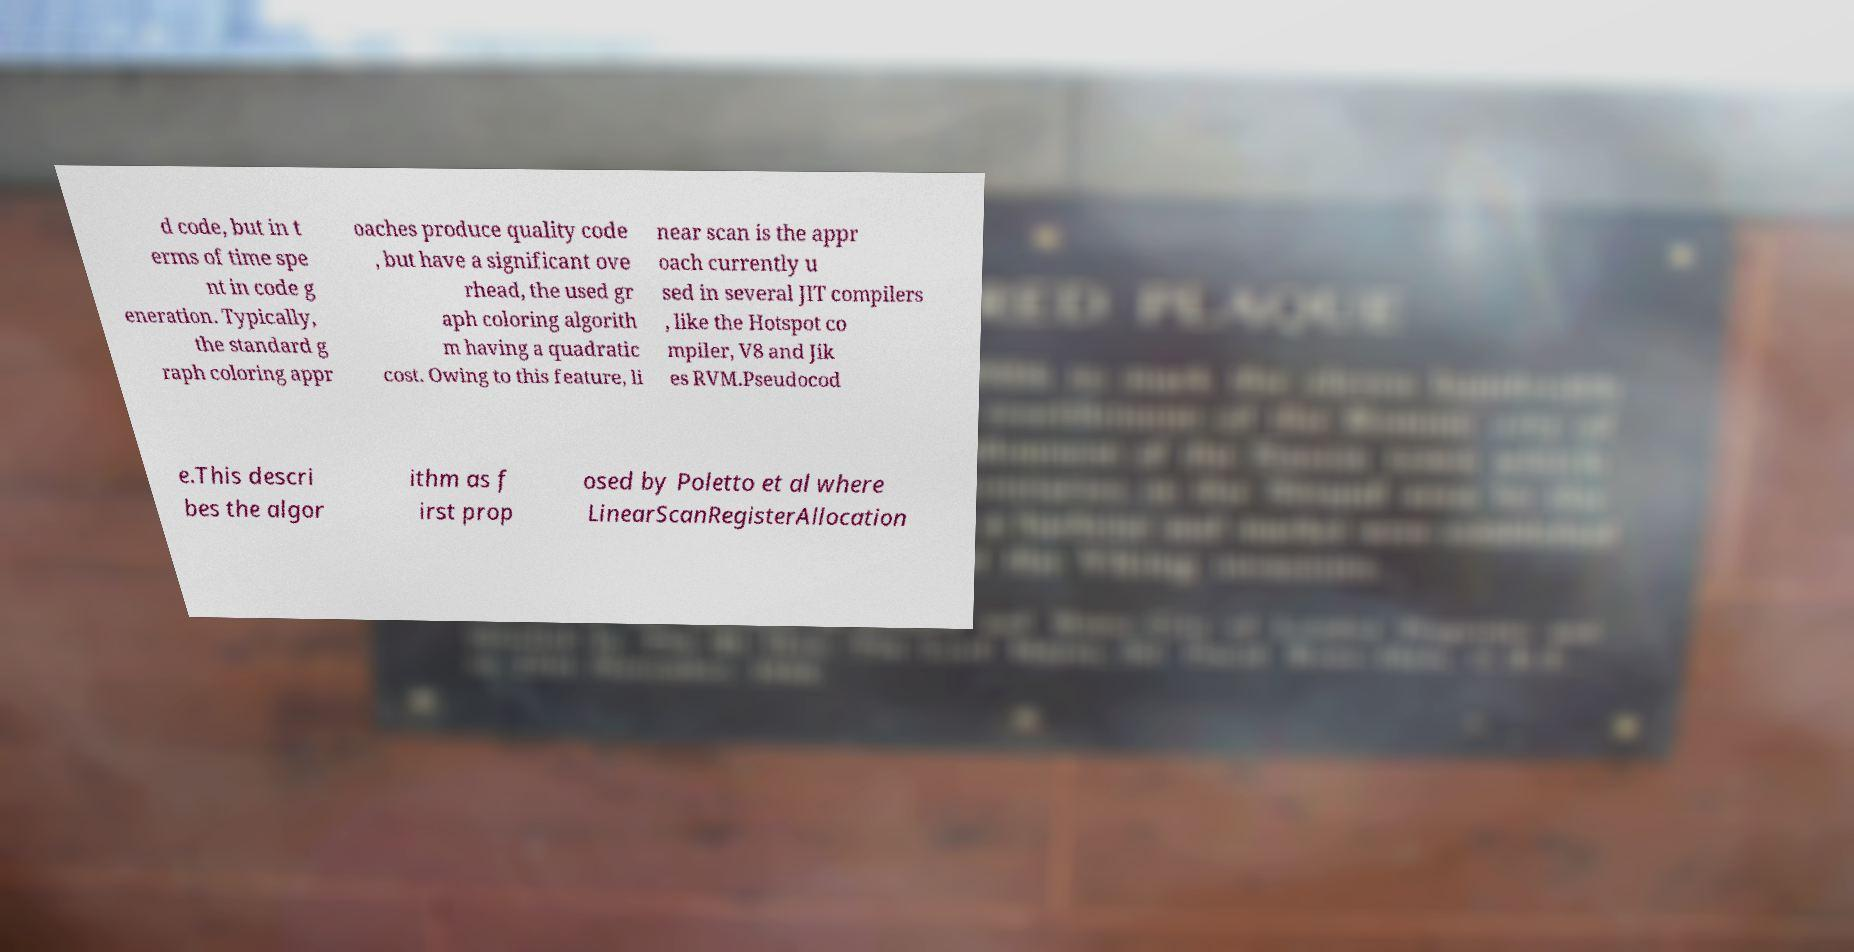Could you extract and type out the text from this image? d code, but in t erms of time spe nt in code g eneration. Typically, the standard g raph coloring appr oaches produce quality code , but have a significant ove rhead, the used gr aph coloring algorith m having a quadratic cost. Owing to this feature, li near scan is the appr oach currently u sed in several JIT compilers , like the Hotspot co mpiler, V8 and Jik es RVM.Pseudocod e.This descri bes the algor ithm as f irst prop osed by Poletto et al where LinearScanRegisterAllocation 